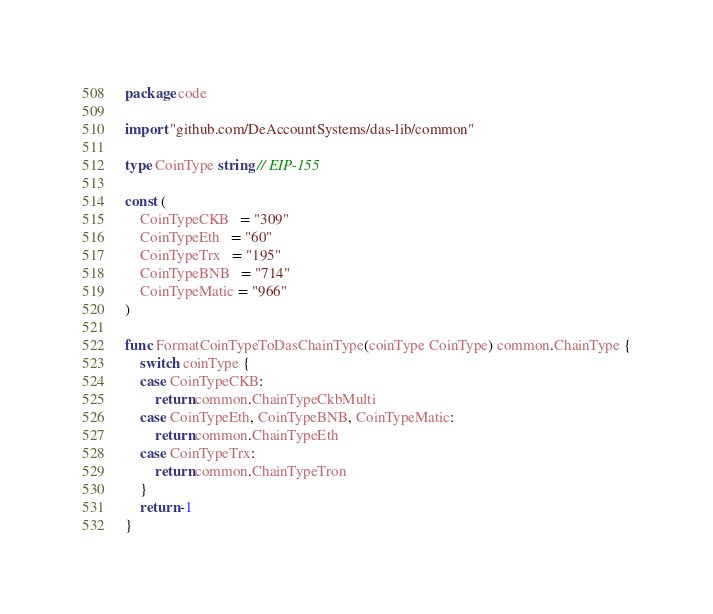<code> <loc_0><loc_0><loc_500><loc_500><_Go_>package code

import "github.com/DeAccountSystems/das-lib/common"

type CoinType string // EIP-155

const (
	CoinTypeCKB   = "309"
	CoinTypeEth   = "60"
	CoinTypeTrx   = "195"
	CoinTypeBNB   = "714"
	CoinTypeMatic = "966"
)

func FormatCoinTypeToDasChainType(coinType CoinType) common.ChainType {
	switch coinType {
	case CoinTypeCKB:
		return common.ChainTypeCkbMulti
	case CoinTypeEth, CoinTypeBNB, CoinTypeMatic:
		return common.ChainTypeEth
	case CoinTypeTrx:
		return common.ChainTypeTron
	}
	return -1
}
</code> 